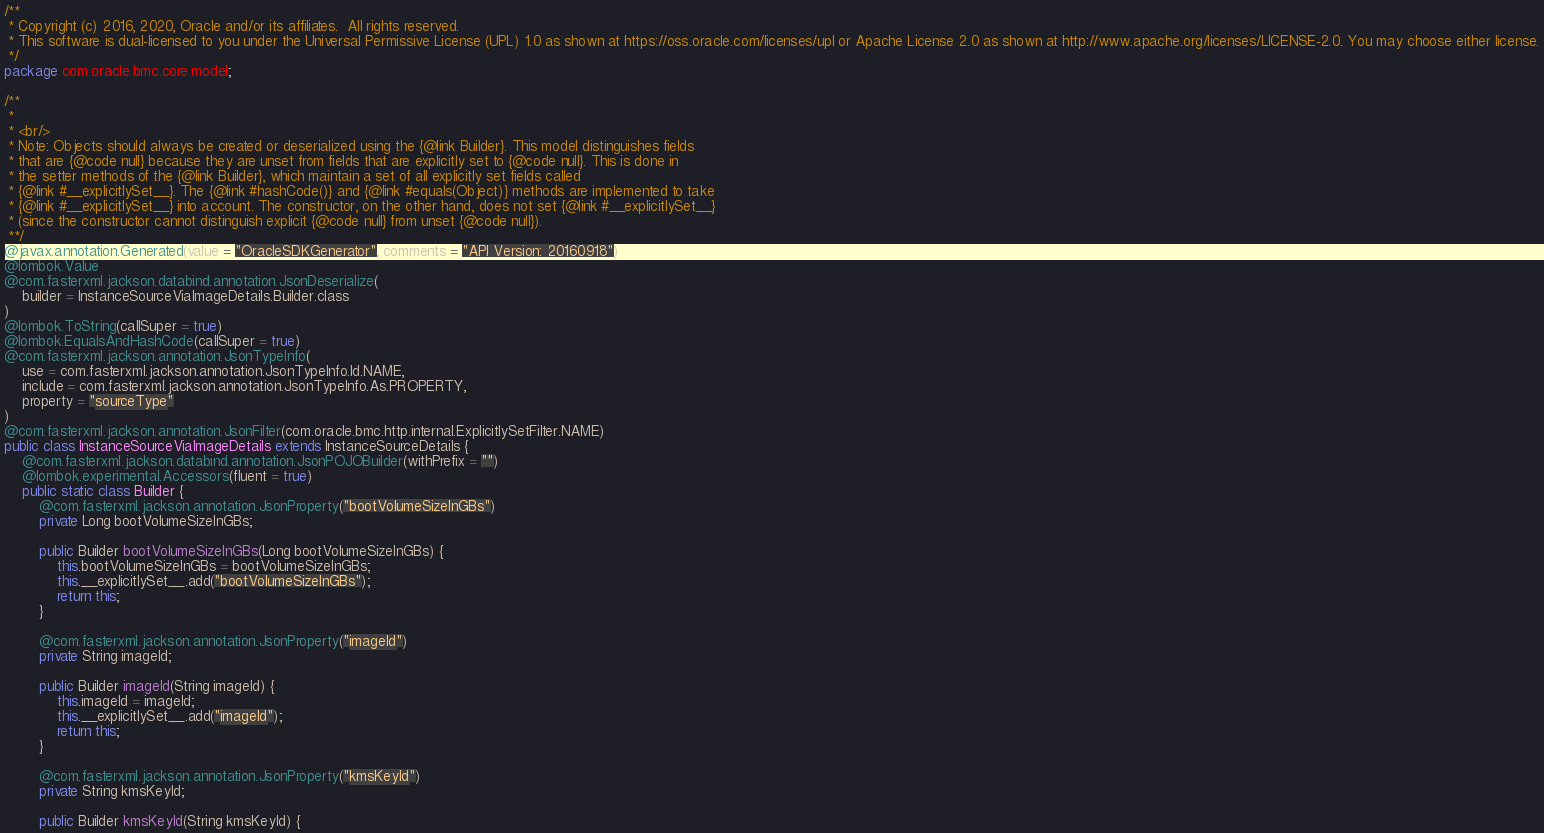Convert code to text. <code><loc_0><loc_0><loc_500><loc_500><_Java_>/**
 * Copyright (c) 2016, 2020, Oracle and/or its affiliates.  All rights reserved.
 * This software is dual-licensed to you under the Universal Permissive License (UPL) 1.0 as shown at https://oss.oracle.com/licenses/upl or Apache License 2.0 as shown at http://www.apache.org/licenses/LICENSE-2.0. You may choose either license.
 */
package com.oracle.bmc.core.model;

/**
 *
 * <br/>
 * Note: Objects should always be created or deserialized using the {@link Builder}. This model distinguishes fields
 * that are {@code null} because they are unset from fields that are explicitly set to {@code null}. This is done in
 * the setter methods of the {@link Builder}, which maintain a set of all explicitly set fields called
 * {@link #__explicitlySet__}. The {@link #hashCode()} and {@link #equals(Object)} methods are implemented to take
 * {@link #__explicitlySet__} into account. The constructor, on the other hand, does not set {@link #__explicitlySet__}
 * (since the constructor cannot distinguish explicit {@code null} from unset {@code null}).
 **/
@javax.annotation.Generated(value = "OracleSDKGenerator", comments = "API Version: 20160918")
@lombok.Value
@com.fasterxml.jackson.databind.annotation.JsonDeserialize(
    builder = InstanceSourceViaImageDetails.Builder.class
)
@lombok.ToString(callSuper = true)
@lombok.EqualsAndHashCode(callSuper = true)
@com.fasterxml.jackson.annotation.JsonTypeInfo(
    use = com.fasterxml.jackson.annotation.JsonTypeInfo.Id.NAME,
    include = com.fasterxml.jackson.annotation.JsonTypeInfo.As.PROPERTY,
    property = "sourceType"
)
@com.fasterxml.jackson.annotation.JsonFilter(com.oracle.bmc.http.internal.ExplicitlySetFilter.NAME)
public class InstanceSourceViaImageDetails extends InstanceSourceDetails {
    @com.fasterxml.jackson.databind.annotation.JsonPOJOBuilder(withPrefix = "")
    @lombok.experimental.Accessors(fluent = true)
    public static class Builder {
        @com.fasterxml.jackson.annotation.JsonProperty("bootVolumeSizeInGBs")
        private Long bootVolumeSizeInGBs;

        public Builder bootVolumeSizeInGBs(Long bootVolumeSizeInGBs) {
            this.bootVolumeSizeInGBs = bootVolumeSizeInGBs;
            this.__explicitlySet__.add("bootVolumeSizeInGBs");
            return this;
        }

        @com.fasterxml.jackson.annotation.JsonProperty("imageId")
        private String imageId;

        public Builder imageId(String imageId) {
            this.imageId = imageId;
            this.__explicitlySet__.add("imageId");
            return this;
        }

        @com.fasterxml.jackson.annotation.JsonProperty("kmsKeyId")
        private String kmsKeyId;

        public Builder kmsKeyId(String kmsKeyId) {</code> 